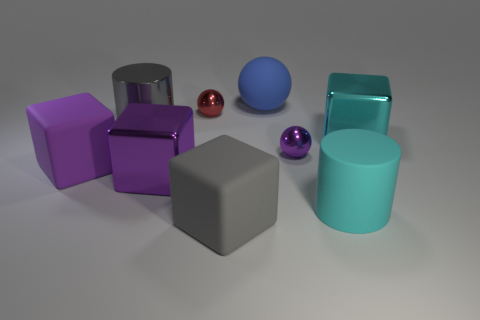Subtract all large blue matte balls. How many balls are left? 2 Subtract all green balls. How many purple cubes are left? 2 Subtract all red balls. How many balls are left? 2 Subtract 1 cylinders. How many cylinders are left? 1 Add 4 small metallic spheres. How many small metallic spheres exist? 6 Subtract 1 cyan cubes. How many objects are left? 8 Subtract all cubes. How many objects are left? 5 Subtract all cyan cylinders. Subtract all cyan blocks. How many cylinders are left? 1 Subtract all large matte cylinders. Subtract all metal blocks. How many objects are left? 6 Add 2 big rubber cubes. How many big rubber cubes are left? 4 